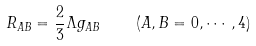<formula> <loc_0><loc_0><loc_500><loc_500>R _ { A B } = \frac { 2 } { 3 } \Lambda g _ { A B } \quad ( A , B = 0 , \cdots , 4 )</formula> 